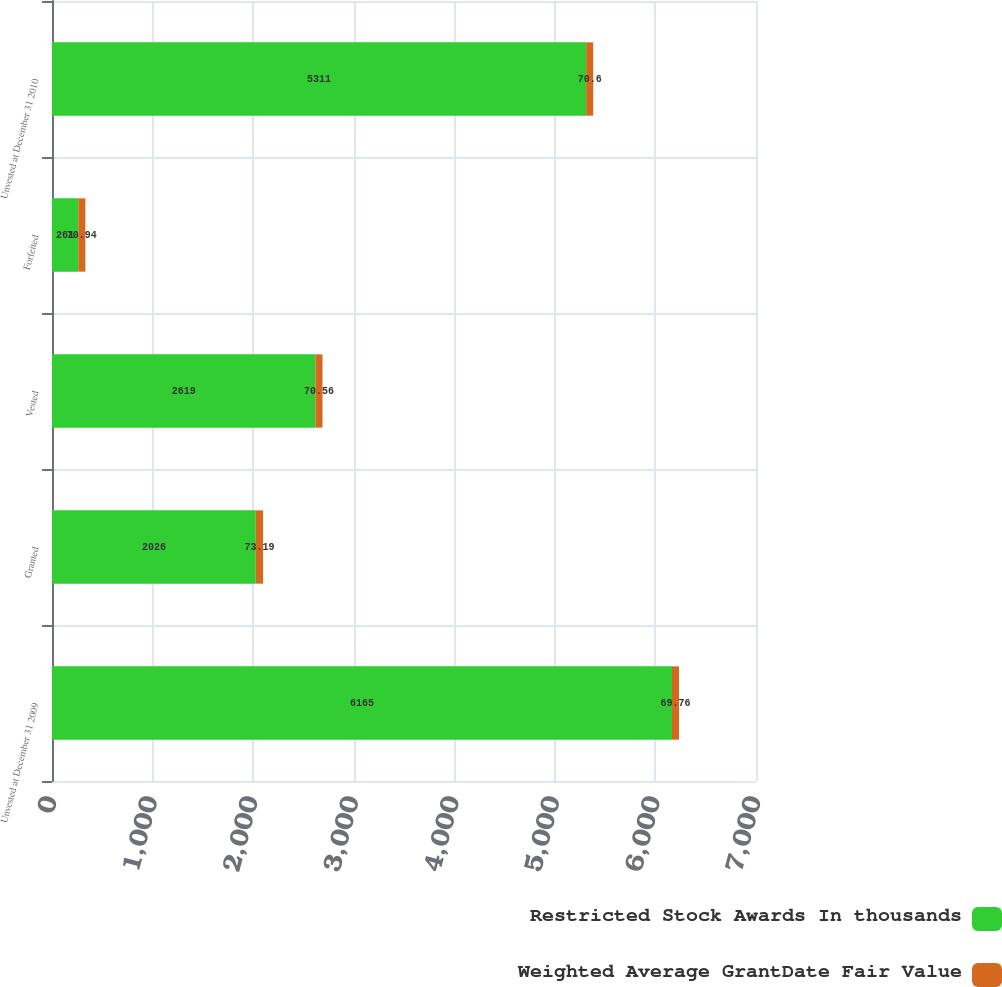Convert chart. <chart><loc_0><loc_0><loc_500><loc_500><stacked_bar_chart><ecel><fcel>Unvested at December 31 2009<fcel>Granted<fcel>Vested<fcel>Forfeited<fcel>Unvested at December 31 2010<nl><fcel>Restricted Stock Awards In thousands<fcel>6165<fcel>2026<fcel>2619<fcel>261<fcel>5311<nl><fcel>Weighted Average GrantDate Fair Value<fcel>69.76<fcel>73.19<fcel>70.56<fcel>70.94<fcel>70.6<nl></chart> 